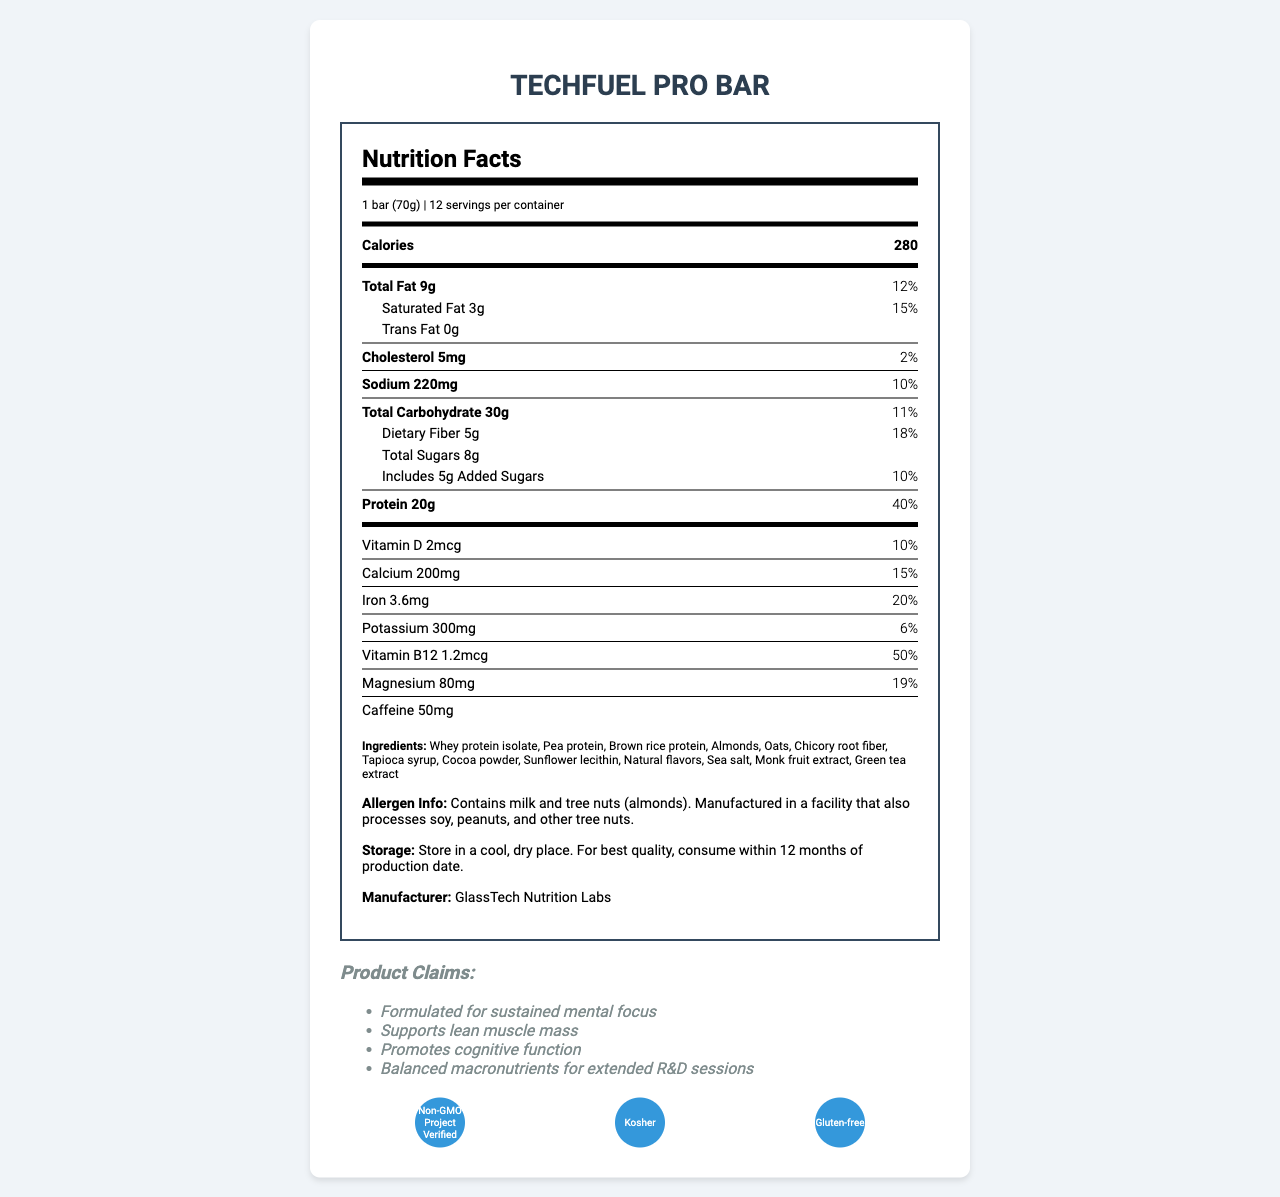what is the product name? The product name is clearly stated at the beginning of the document.
Answer: TechFuel Pro Bar what is the serving size? The serving size is specified as "1 bar (70g)" in the document.
Answer: 1 bar (70g) how many servings are there per container? The document states that there are 12 servings per container.
Answer: 12 how many total grams of fat does one serving contain? The total fat content per serving is listed as "9g".
Answer: 9g what is the amount of protein in one bar? The protein content is listed as "20g" per serving.
Answer: 20g what is the daily value percentage of calcium per serving? The calcium daily value percentage is given as "15%" in the document.
Answer: 15% how much caffeine is in each bar? A. 20mg B. 50mg C. 100mg The document states that each bar contains "50mg" of caffeine.
Answer: B. 50mg which of the following is NOT an ingredient in the TechFuel Pro Bar? A. Almonds B. Peanuts C. Cocoa powder The ingredient list includes almonds and cocoa powder but does not mention peanuts.
Answer: B. Peanuts is the product gluten-free? The document specifies that one of the certifications is "Gluten-free".
Answer: Yes what element has the highest daily value percentage in a single serving? The highest daily value percentage listed is "50%" for Vitamin B12.
Answer: Vitamin B12 what are the total calories in one serving? The document lists the total calories per serving as "280".
Answer: 280 what storage instructions are provided for the TechFuel Pro Bar? The storage instructions are clearly detailed in the document.
Answer: Store in a cool, dry place. For best quality, consume within 12 months of production date. does the product contain any added sugars? The document specifies "Includes 5g Added Sugars".
Answer: Yes summarize the main claims made about the TechFuel Pro Bar. The summary includes all the key product claims listed in the document.
Answer: The TechFuel Pro Bar is formulated for sustained mental focus, supports lean muscle mass, promotes cognitive function, and provides balanced macronutrients for extended R&D sessions. what are the non-GMO certifications for the TechFuel Pro Bar? The document mentions "Non-GMO Project Verified" as a certification but does not provide specific details about the non-GMO certifications.
Answer: Cannot be determined what company manufactures the TechFuel Pro Bar? The manufacturer is listed as "GlassTech Nutrition Labs" in the document.
Answer: GlassTech Nutrition Labs which allergens are present in the TechFuel Pro Bar? The allergen information provided mentions milk and tree nuts (almonds).
Answer: Contains milk and tree nuts (almonds). 